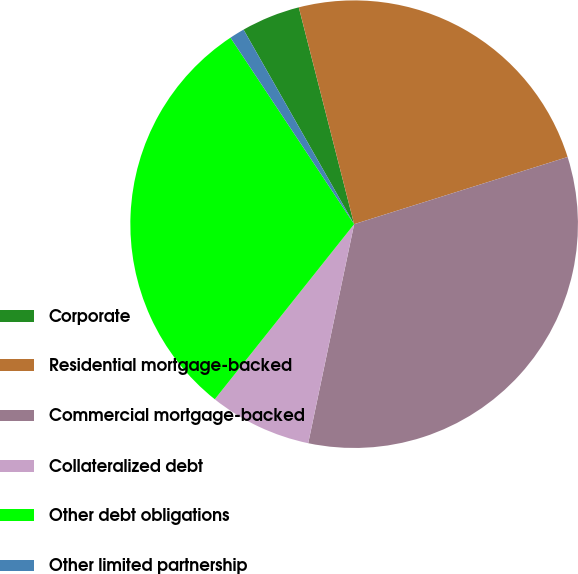Convert chart. <chart><loc_0><loc_0><loc_500><loc_500><pie_chart><fcel>Corporate<fcel>Residential mortgage-backed<fcel>Commercial mortgage-backed<fcel>Collateralized debt<fcel>Other debt obligations<fcel>Other limited partnership<nl><fcel>4.25%<fcel>24.13%<fcel>33.15%<fcel>7.41%<fcel>29.99%<fcel>1.09%<nl></chart> 